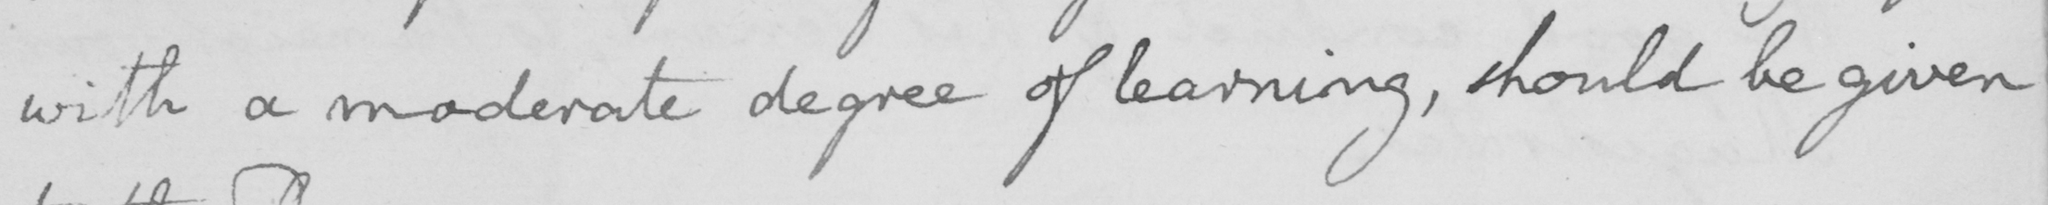Transcribe the text shown in this historical manuscript line. with a moderate degree of learning , should be given 